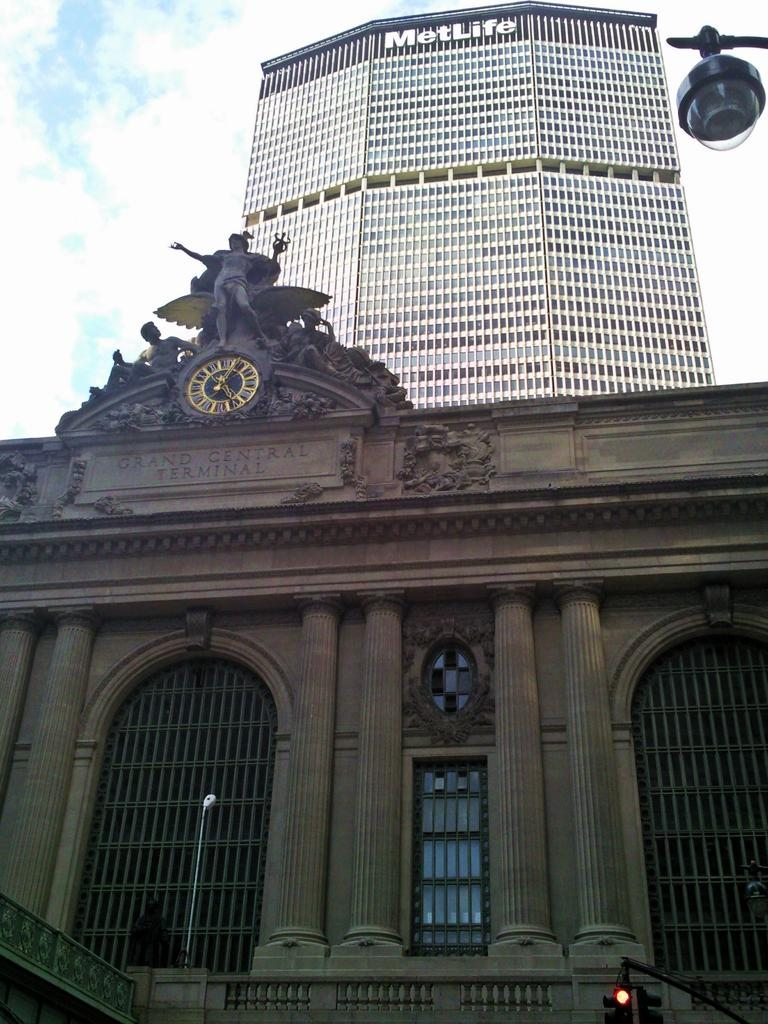Provide a one-sentence caption for the provided image. The Grand Central Terminal has a backdrop of the Met Life Building. 